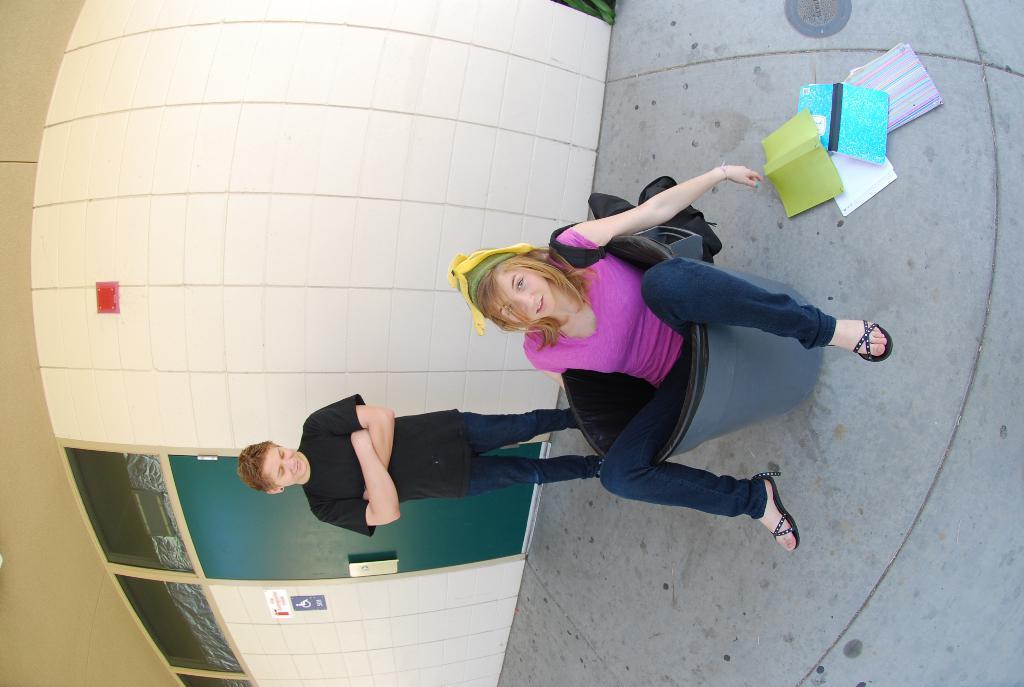Could you give a brief overview of what you see in this image? In the center of the image we can see a girl is sitting on a chair. On the right side of the image we can see the floor and books. On the left side of the image we can see the wall, roof, door, posters on the wall and a person is standing. 